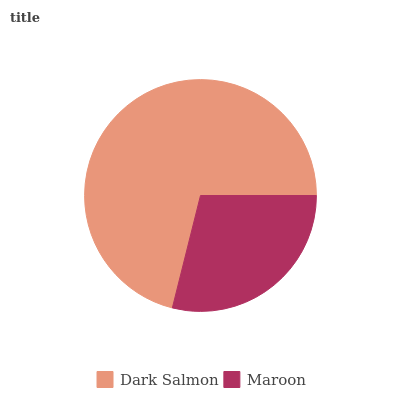Is Maroon the minimum?
Answer yes or no. Yes. Is Dark Salmon the maximum?
Answer yes or no. Yes. Is Maroon the maximum?
Answer yes or no. No. Is Dark Salmon greater than Maroon?
Answer yes or no. Yes. Is Maroon less than Dark Salmon?
Answer yes or no. Yes. Is Maroon greater than Dark Salmon?
Answer yes or no. No. Is Dark Salmon less than Maroon?
Answer yes or no. No. Is Dark Salmon the high median?
Answer yes or no. Yes. Is Maroon the low median?
Answer yes or no. Yes. Is Maroon the high median?
Answer yes or no. No. Is Dark Salmon the low median?
Answer yes or no. No. 